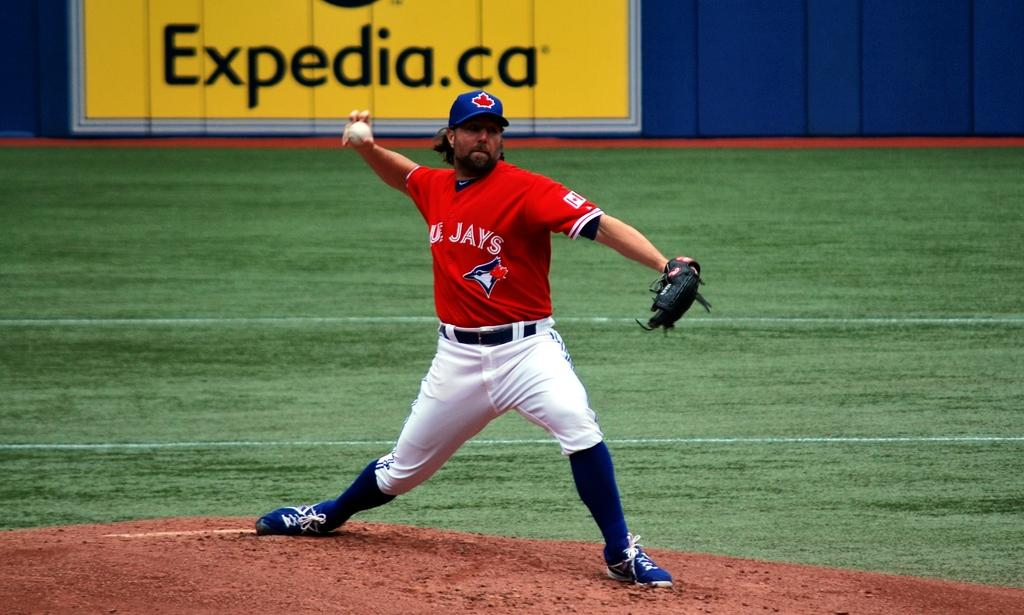<image>
Write a terse but informative summary of the picture. An Expedia.ca sign is along the edge of the baseball field. 